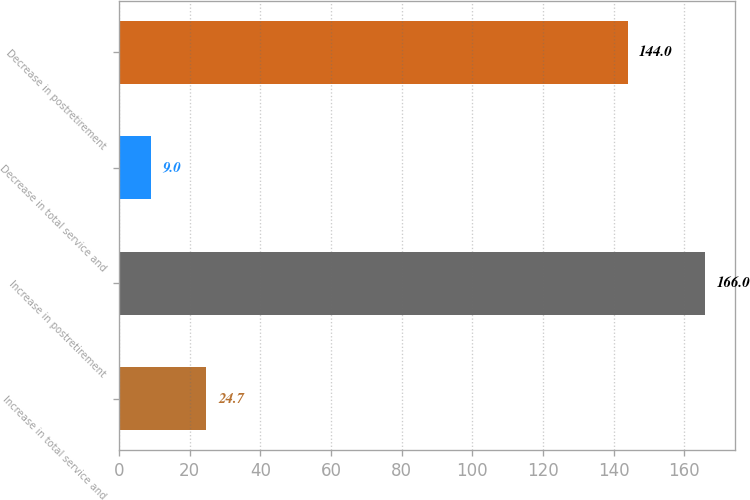Convert chart. <chart><loc_0><loc_0><loc_500><loc_500><bar_chart><fcel>Increase in total service and<fcel>Increase in postretirement<fcel>Decrease in total service and<fcel>Decrease in postretirement<nl><fcel>24.7<fcel>166<fcel>9<fcel>144<nl></chart> 